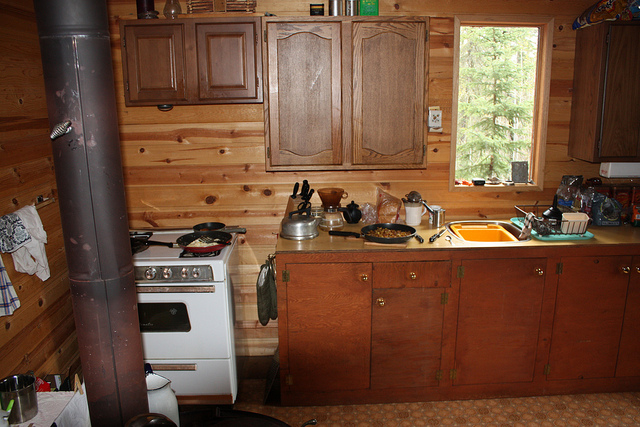<image>Where is the kettle? I don't know where the kettle is. It can be on the counter. Where is the kettle? The kettle is on the counter. 